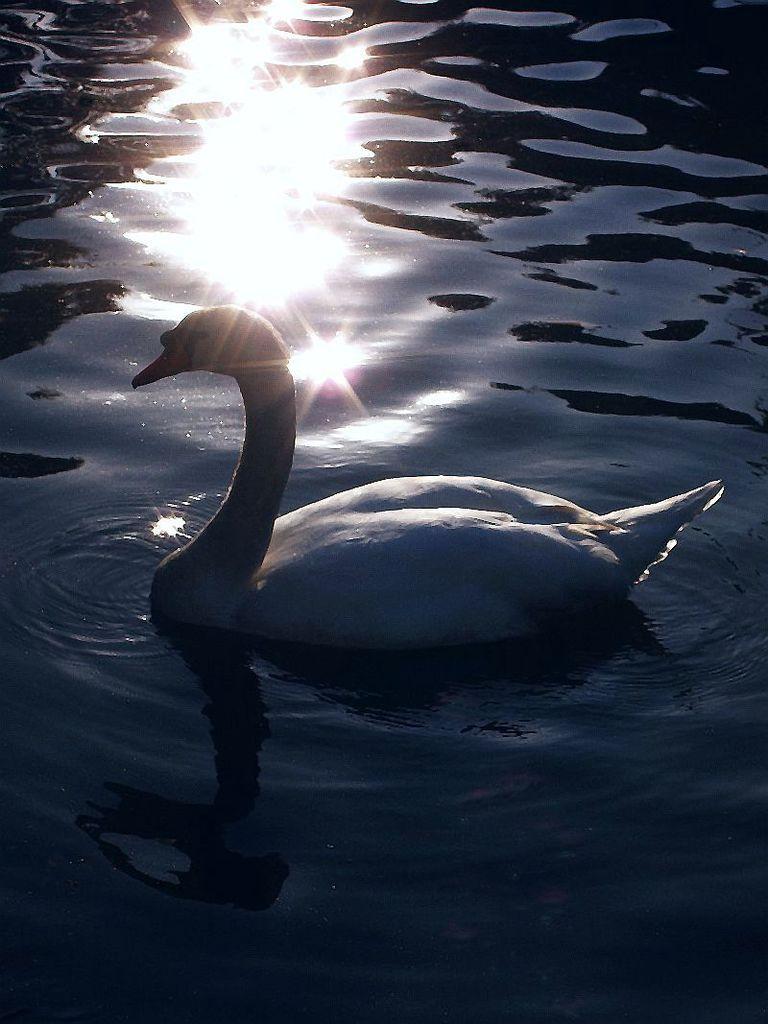Could you give a brief overview of what you see in this image? In this image I can see water and on it I can see a white colour swan in the front. 